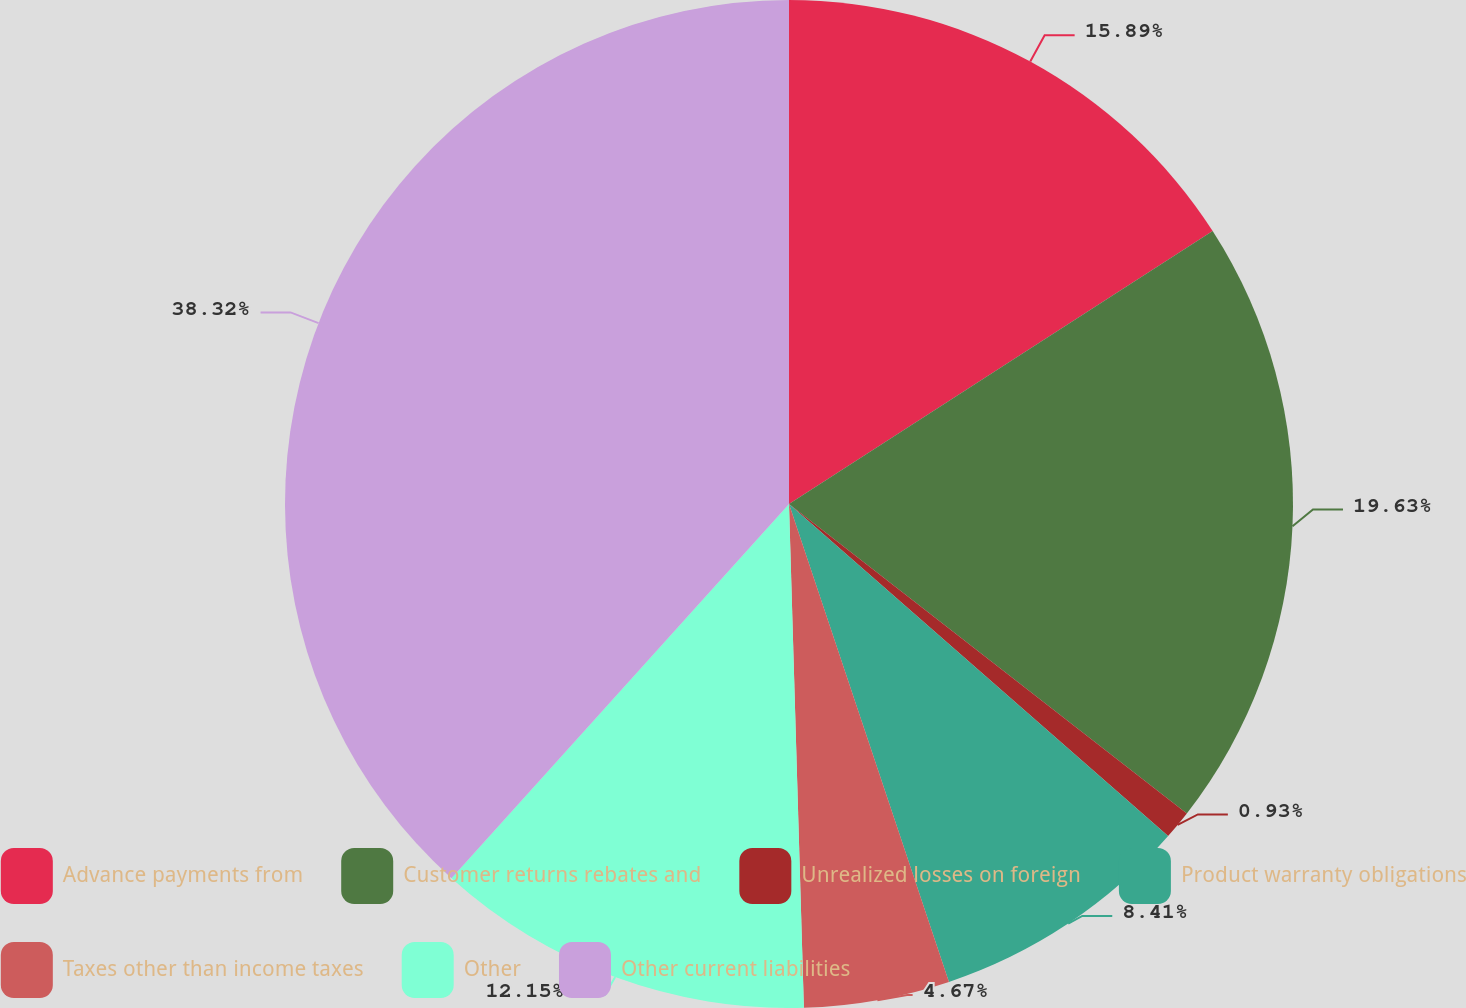<chart> <loc_0><loc_0><loc_500><loc_500><pie_chart><fcel>Advance payments from<fcel>Customer returns rebates and<fcel>Unrealized losses on foreign<fcel>Product warranty obligations<fcel>Taxes other than income taxes<fcel>Other<fcel>Other current liabilities<nl><fcel>15.89%<fcel>19.63%<fcel>0.93%<fcel>8.41%<fcel>4.67%<fcel>12.15%<fcel>38.32%<nl></chart> 